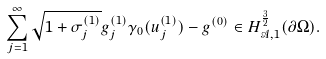<formula> <loc_0><loc_0><loc_500><loc_500>\sum _ { j = 1 } ^ { \infty } \sqrt { 1 + \sigma _ { j } ^ { ( 1 ) } } g _ { j } ^ { ( 1 ) } \gamma _ { 0 } ( u _ { j } ^ { ( 1 ) } ) - g ^ { ( 0 ) } \in H ^ { \frac { 3 } { 2 } } _ { \mathcal { A } , 1 } ( \partial \Omega ) .</formula> 